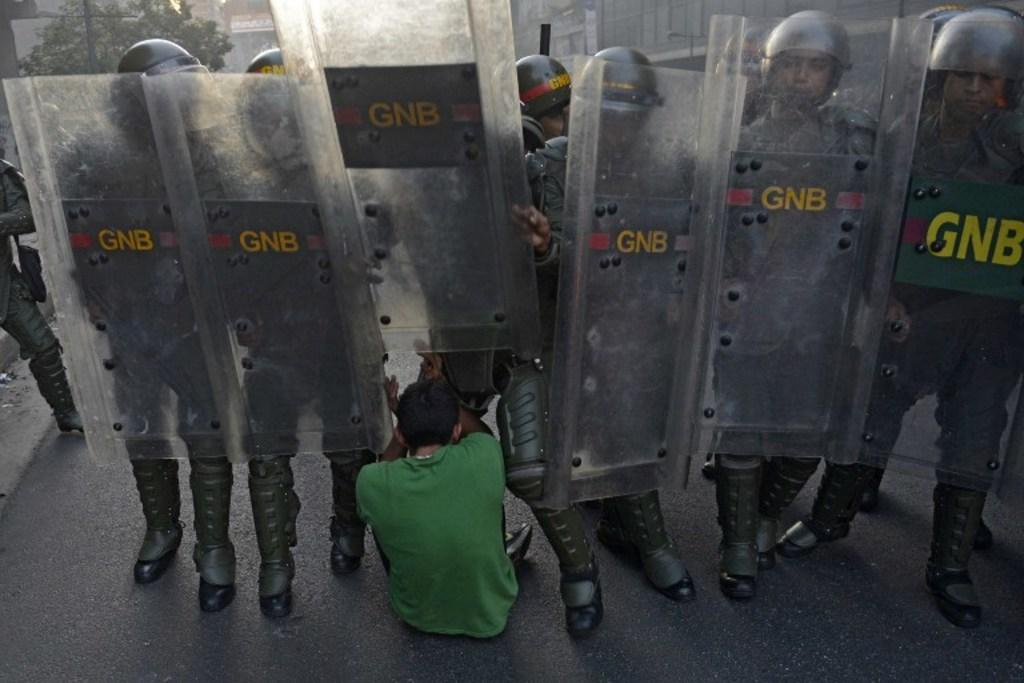What is the person in the image doing? There is a person sitting on the road in the image. What is the person wearing? The person is wearing a green color t-shirt. What else can be seen in the image? There is a group of police standing in the image. How many snakes are slithering around the person in the image? There are no snakes present in the image. What type of tank can be seen in the image? There is no tank present in the image. 